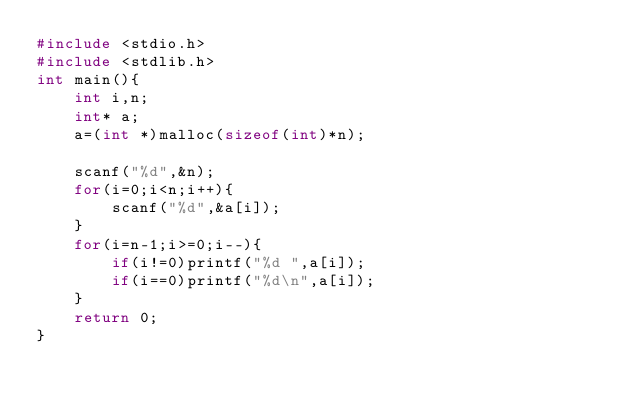<code> <loc_0><loc_0><loc_500><loc_500><_C_>#include <stdio.h>
#include <stdlib.h>
int main(){
	int i,n;
	int* a;
	a=(int *)malloc(sizeof(int)*n);

	scanf("%d",&n);
	for(i=0;i<n;i++){
		scanf("%d",&a[i]);
	}
	for(i=n-1;i>=0;i--){
		if(i!=0)printf("%d ",a[i]);
		if(i==0)printf("%d\n",a[i]);
	}
	return 0;
}</code> 